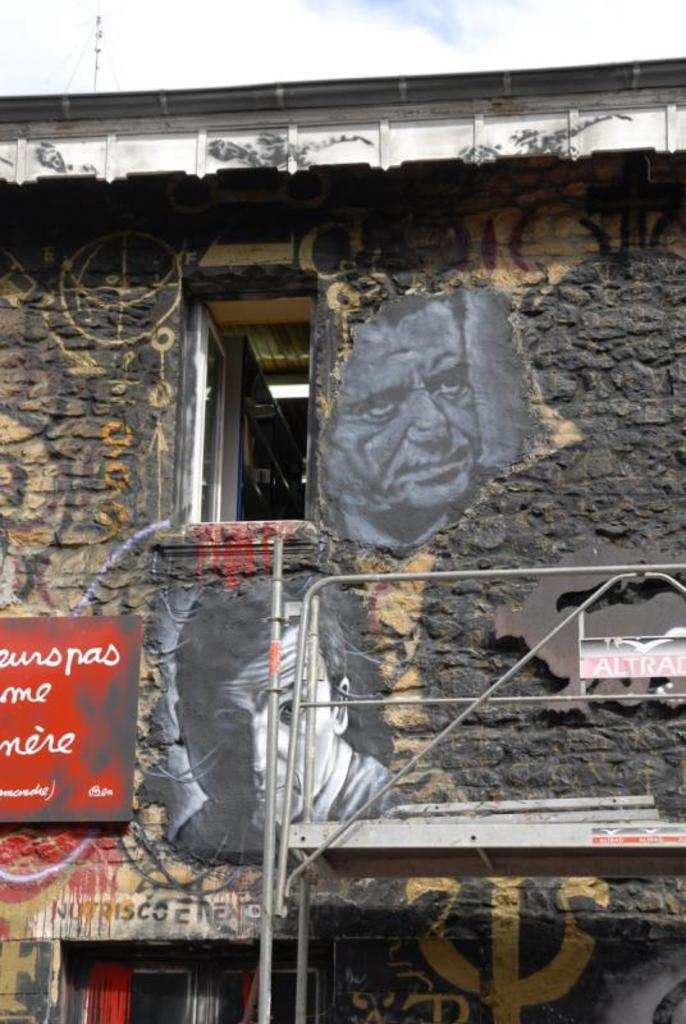What type of structure is present in the image? There is a shed in the image. What can be observed about the wall of the shed? The wall of the shed is painted in black and yellow colors in different shades. What is visible at the top of the image? The sky is visible at the top of the image. Is there an advertisement for a letter or form on the shed's wall? There is no advertisement for a letter or form on the shed's wall in the image. 